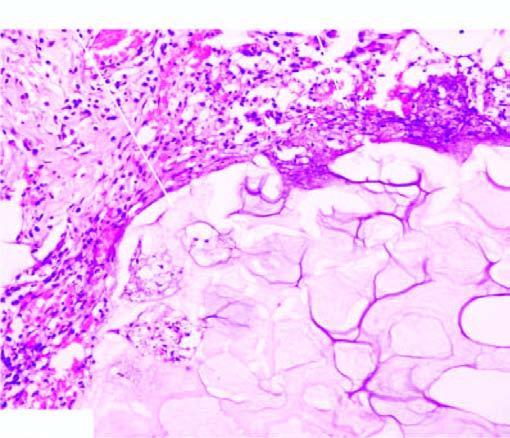does the periphery show a few mixed inflammatory cells?
Answer the question using a single word or phrase. Yes 